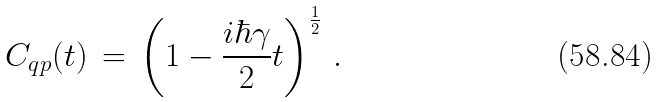<formula> <loc_0><loc_0><loc_500><loc_500>C _ { q p } ( t ) \, = \, \left ( 1 - \frac { i \hbar { \gamma } } { 2 } t \right ) ^ { \frac { 1 } { 2 } } \, .</formula> 